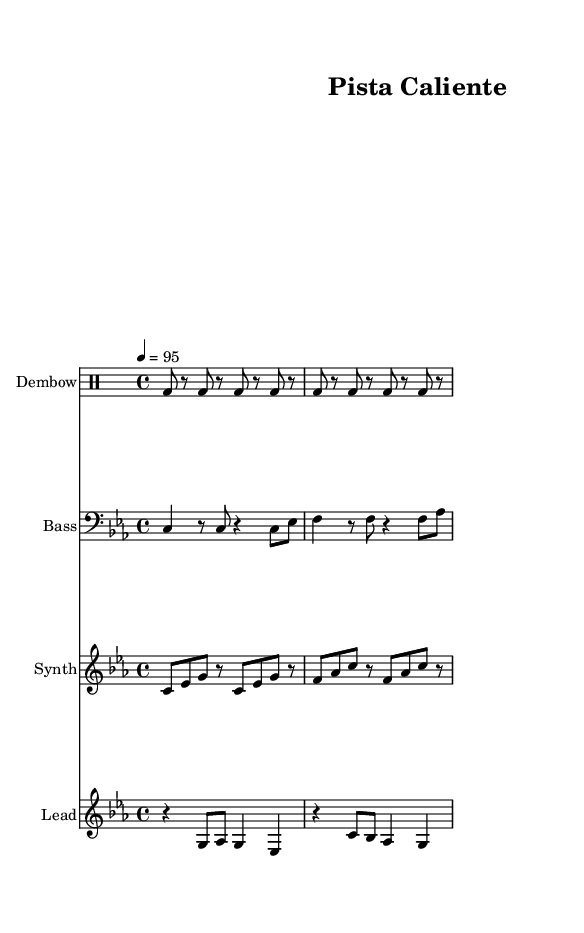What is the key signature of this music? The key signature is C minor, indicated by the presence of three flats. We can identify the key signature at the beginning of the staff where it notes these flats.
Answer: C minor What is the time signature of this piece? The time signature is 4/4, shown at the beginning of the piece. This means there are four beats in each measure and a quarter note receives one beat.
Answer: 4/4 What is the tempo marking for this music? The tempo marking is 4 = 95, which indicates that the quarter note should be played at 95 beats per minute. This information is provided at the start of the score.
Answer: 95 How many measures are in the provided score? The score consists of four measures. Each measure is separated by vertical bars, and counting each segment confirms there are four.
Answer: 4 What rhythmic pattern is used in the drum part? The drum part utilizes a Dembow rhythm, characterized by its distinctive bass drum pattern. It alternates between bass drum hits and rests, creating a core Reggaeton beat. The pattern can be analyzed measure by measure.
Answer: Dembow What is the highest pitch in the lead staff? The highest pitch in the lead staff is G. By examining the notes listed, G appears as the top note in multiple measures, confirming it as the highest pitch.
Answer: G What instrument is represented by the staff labeled "Synth"? The staff labeled "Synth" is designed for a synthesizer, as indicated at the beginning of that particular staff's title. This is common for electronic music styles, including Reggaeton.
Answer: Synth 